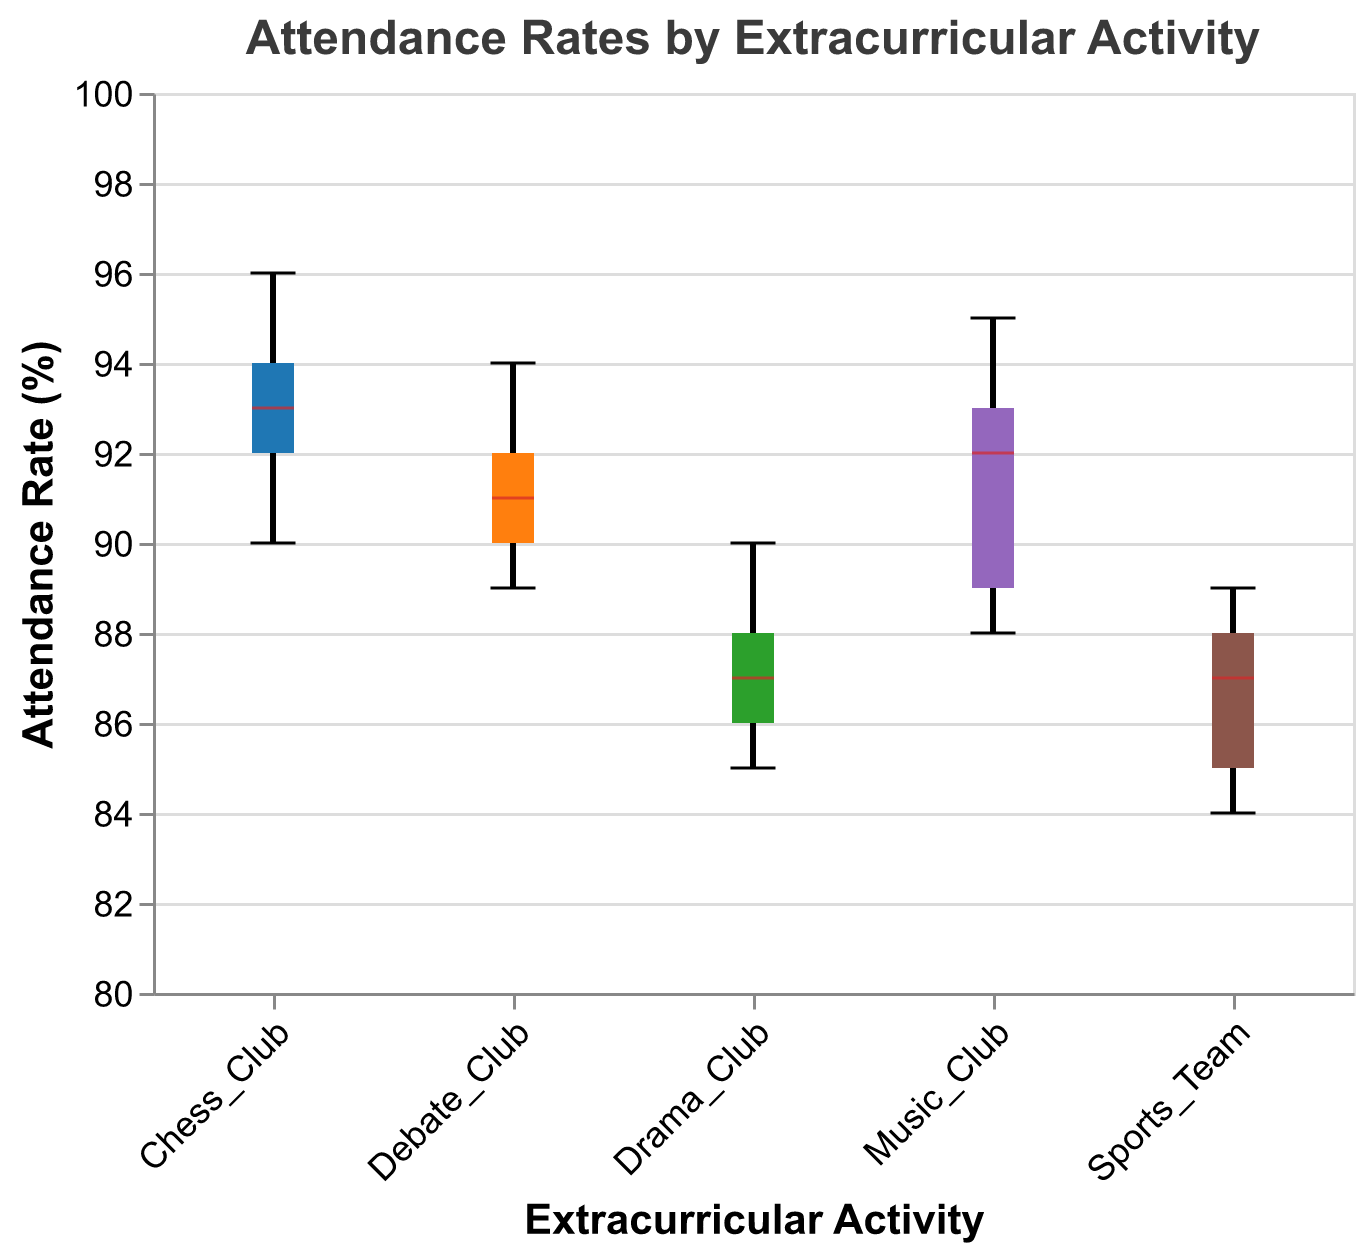What is the title of the box plot? The title is usually located at the top of the figure and directly states what the plot represents. In this case, it tells us what we are seeing in terms of data comparison.
Answer: Attendance Rates by Extracurricular Activity Which extracurricular activity has the highest median attendance rate? The median is indicated by the white line within each box. Observing the positions of these lines will show which activity has the highest median.
Answer: Chess Club Which extracurricular activity has the lowest median attendance rate? Similar to the previous question, we look for the activity whose median (white line) is situated lowest on the y-axis.
Answer: Sports Team How many extracurricular activities are compared in the box plot? The number of unique categories on the x-axis, which corresponds to different groups in the plot, tells us how many activities are being compared.
Answer: 5 Which two extracurricular activities have the closest median attendance rates? By looking at the white line positions (medians) within the boxes and comparing these, we can identify which two are closest to each other.
Answer: Music Club and Debate Club What is the interquartile range (IQR) for Drama Club? The IQR is represented by the height of the box, which stands for the range between the 25th percentile (bottom of the box) and the 75th percentile (top of the box). Estimate these values from the plot and calculate the range.
Answer: 88 - 86 = 2 Which extracurricular activity shows the widest range from minimum to maximum attendance rate? The range is signified by the distance between the top and bottom whiskers. The activity with the widest distance between these two points has the largest range.
Answer: Chess Club Compare the median attendance rates of Music Club and Sports Team. Which is higher and by how much? Check the positions of the medians (white lines) of the two groups. Subtract the lower median from the higher median to find the difference.
Answer: Music Club is higher by 6 points Are there any outliers in the box plot? If so, in which activities do they appear? Outliers, if any, are represented by individual points that lie outside the whiskers. Check each activity to see if such points exist.
Answer: No outliers What is the range of attendance rates for Debate Club? The range is determined by subtracting the minimum value (bottom whisker) from the maximum value (top whisker). Estimate these values from the plot.
Answer: 94 - 89 = 5 